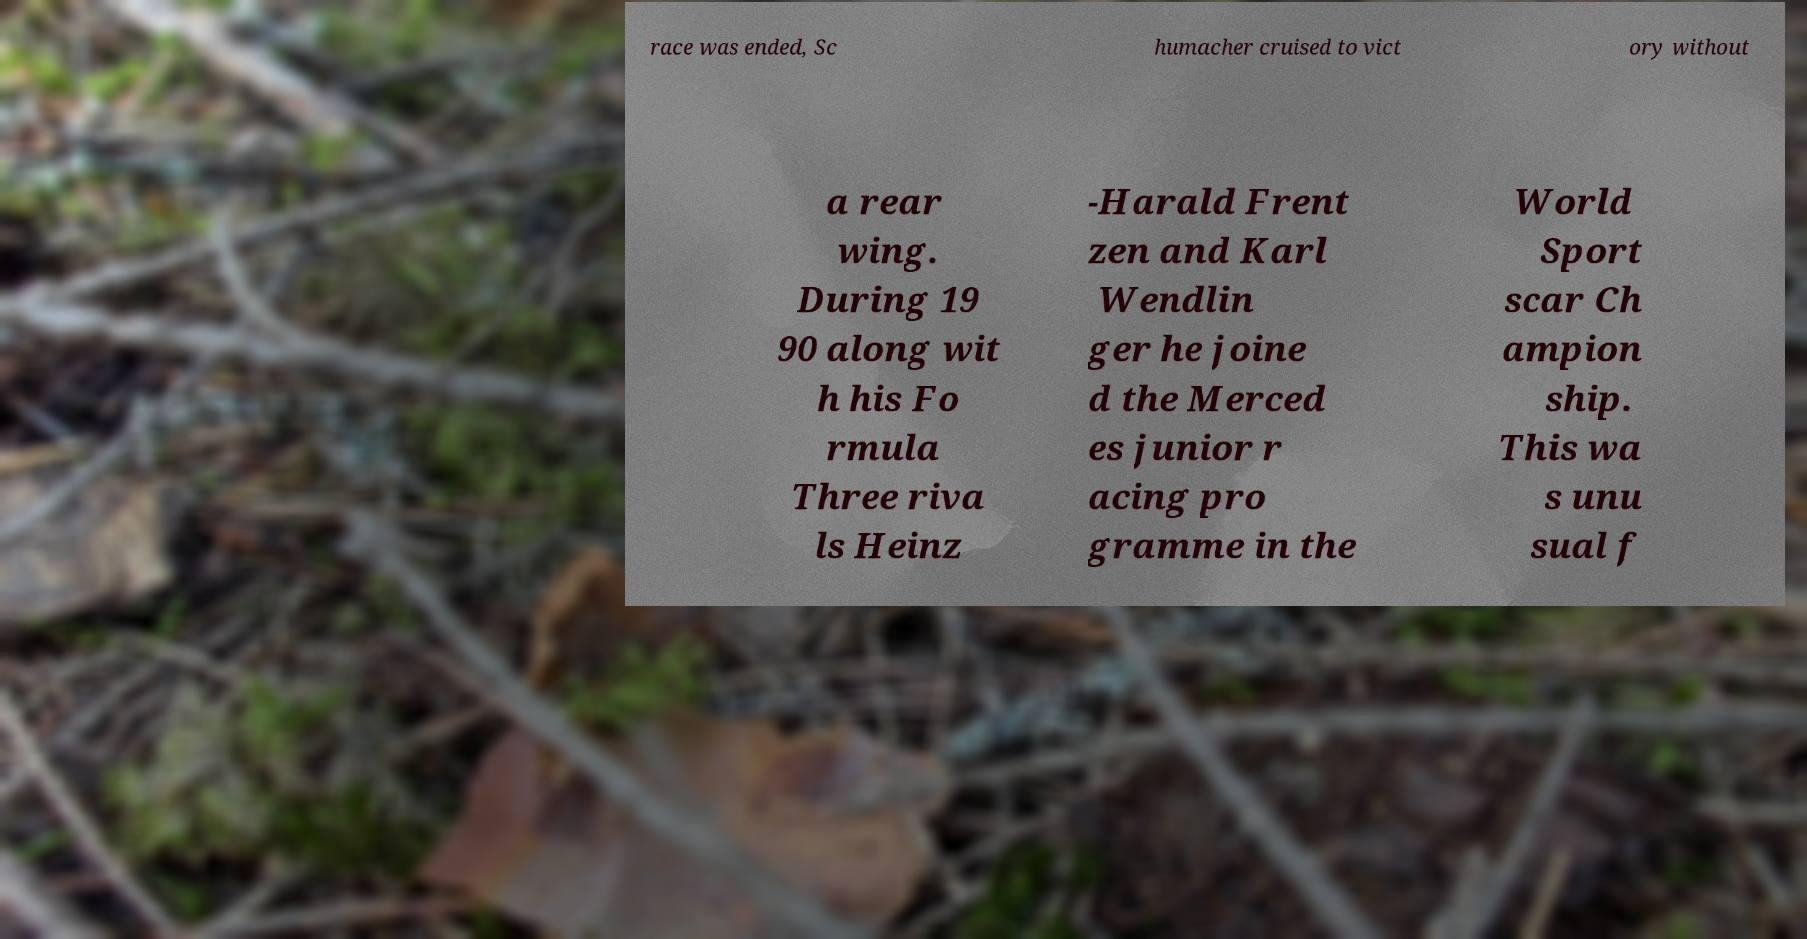For documentation purposes, I need the text within this image transcribed. Could you provide that? race was ended, Sc humacher cruised to vict ory without a rear wing. During 19 90 along wit h his Fo rmula Three riva ls Heinz -Harald Frent zen and Karl Wendlin ger he joine d the Merced es junior r acing pro gramme in the World Sport scar Ch ampion ship. This wa s unu sual f 